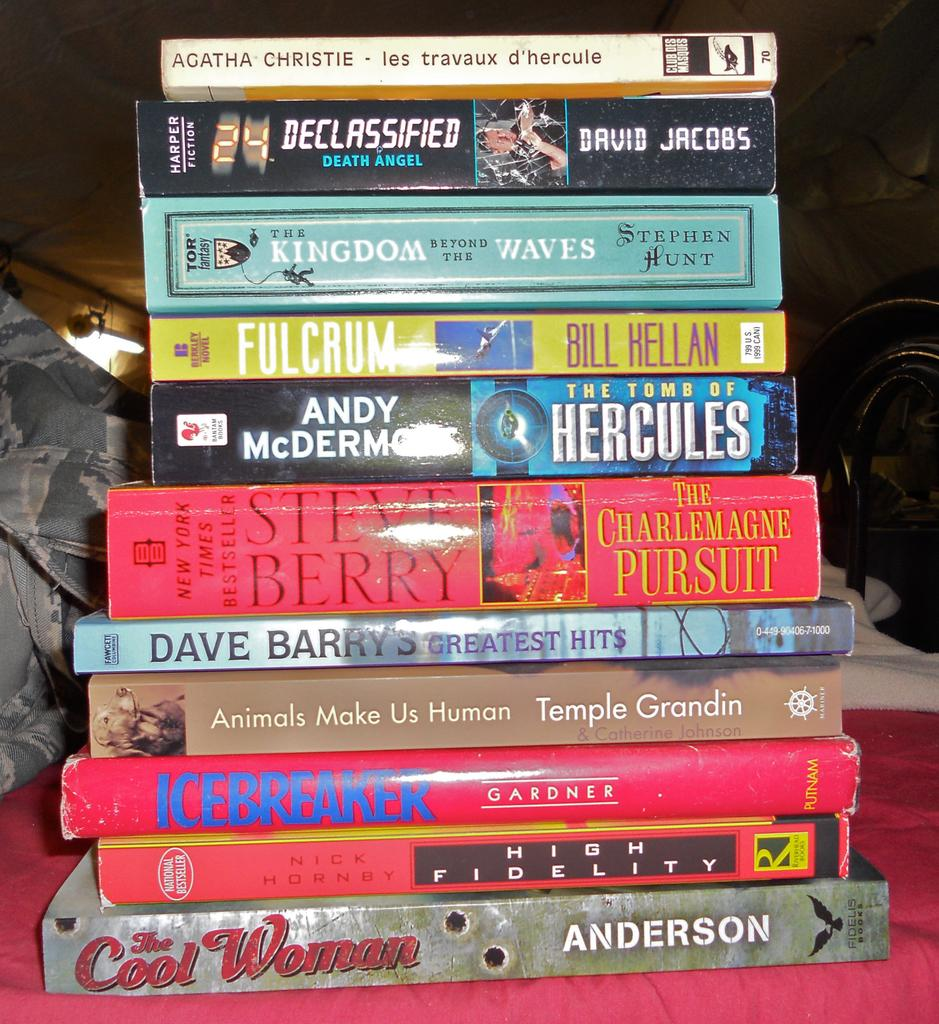<image>
Provide a brief description of the given image. Many books stacked on top of each other one by Steve Berry. 